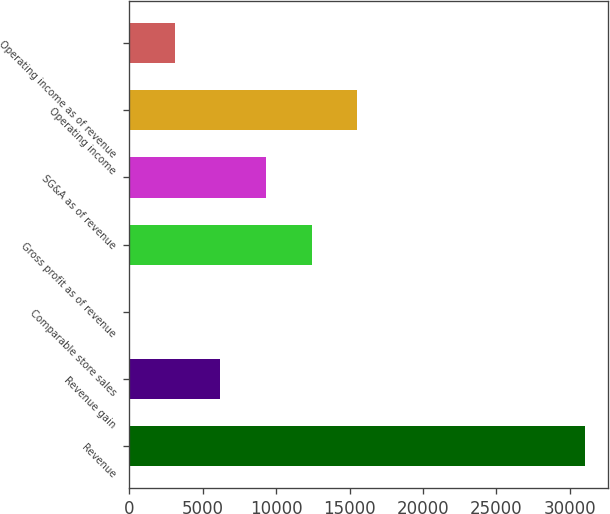Convert chart. <chart><loc_0><loc_0><loc_500><loc_500><bar_chart><fcel>Revenue<fcel>Revenue gain<fcel>Comparable store sales<fcel>Gross profit as of revenue<fcel>SG&A as of revenue<fcel>Operating income<fcel>Operating income as of revenue<nl><fcel>31031<fcel>6209.48<fcel>4.1<fcel>12414.9<fcel>9312.17<fcel>15517.5<fcel>3106.79<nl></chart> 